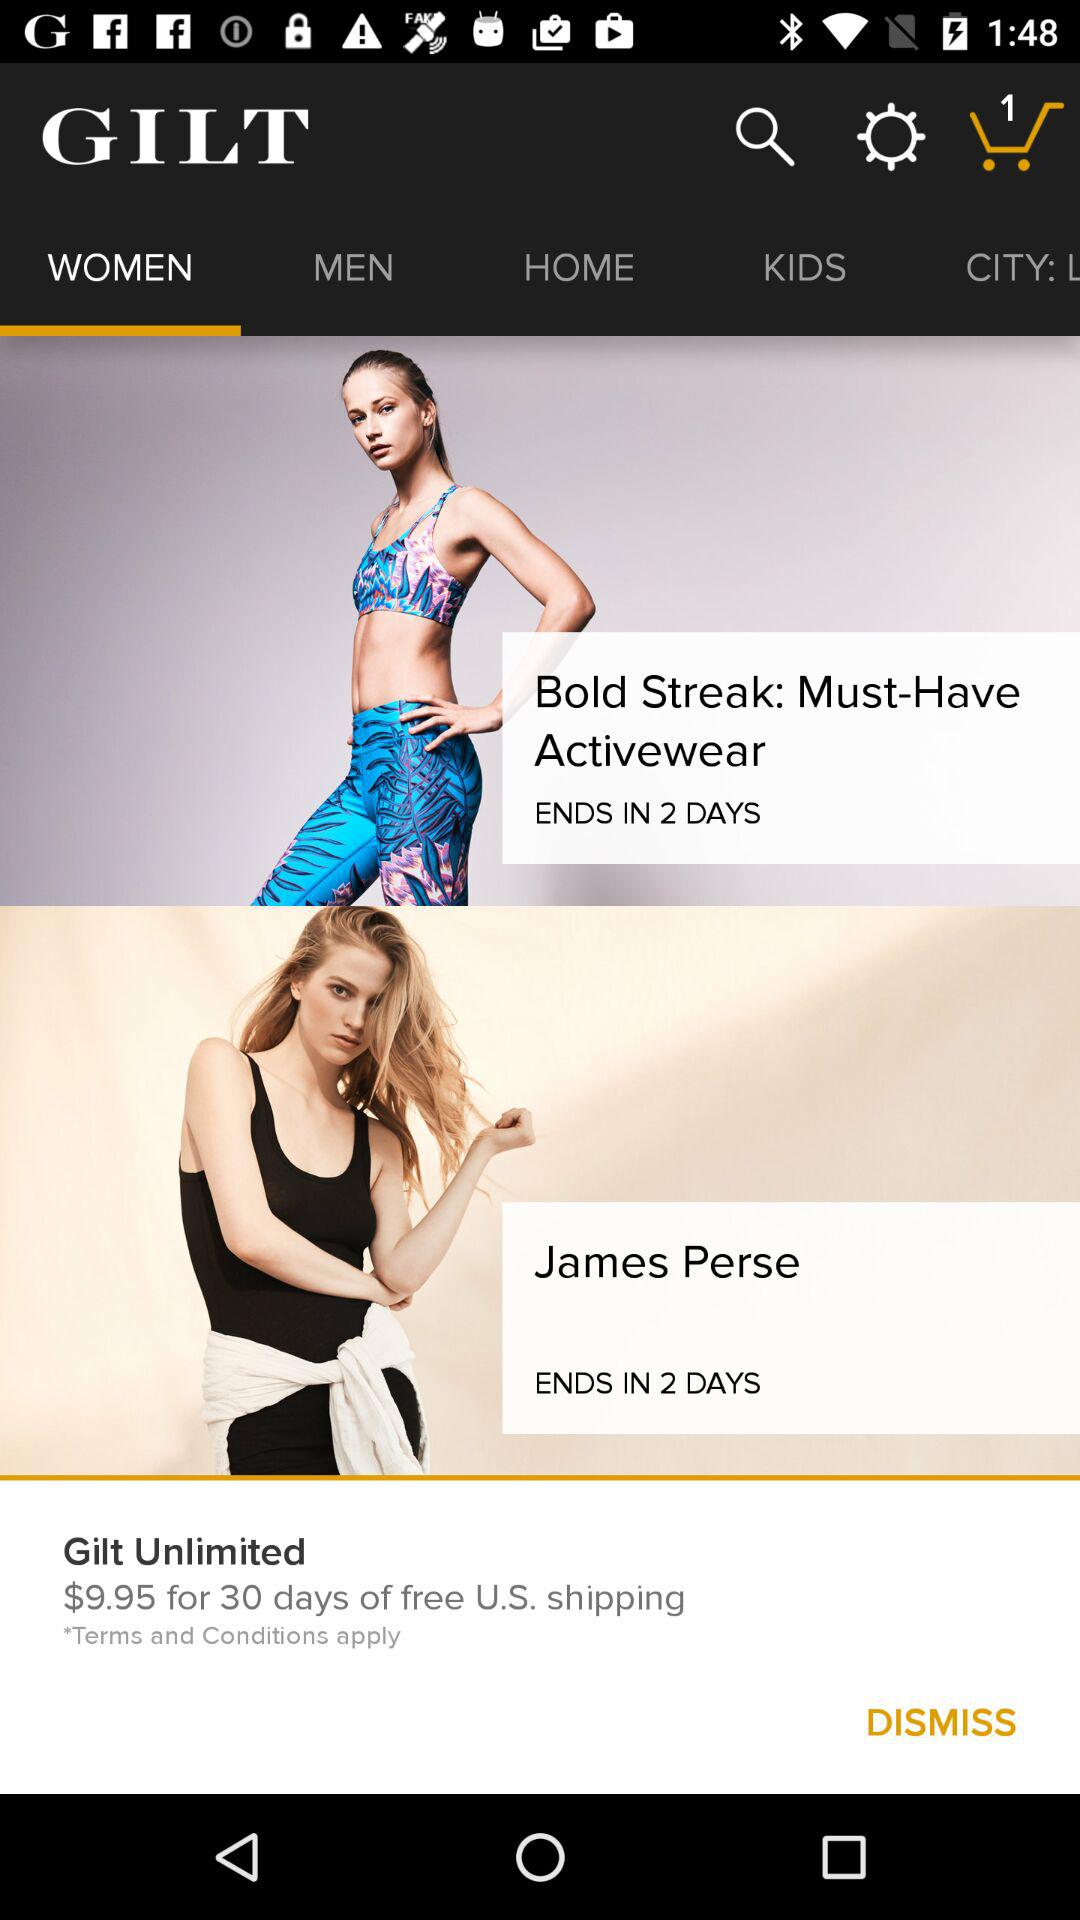How many items are ending in 2 days?
Answer the question using a single word or phrase. 2 